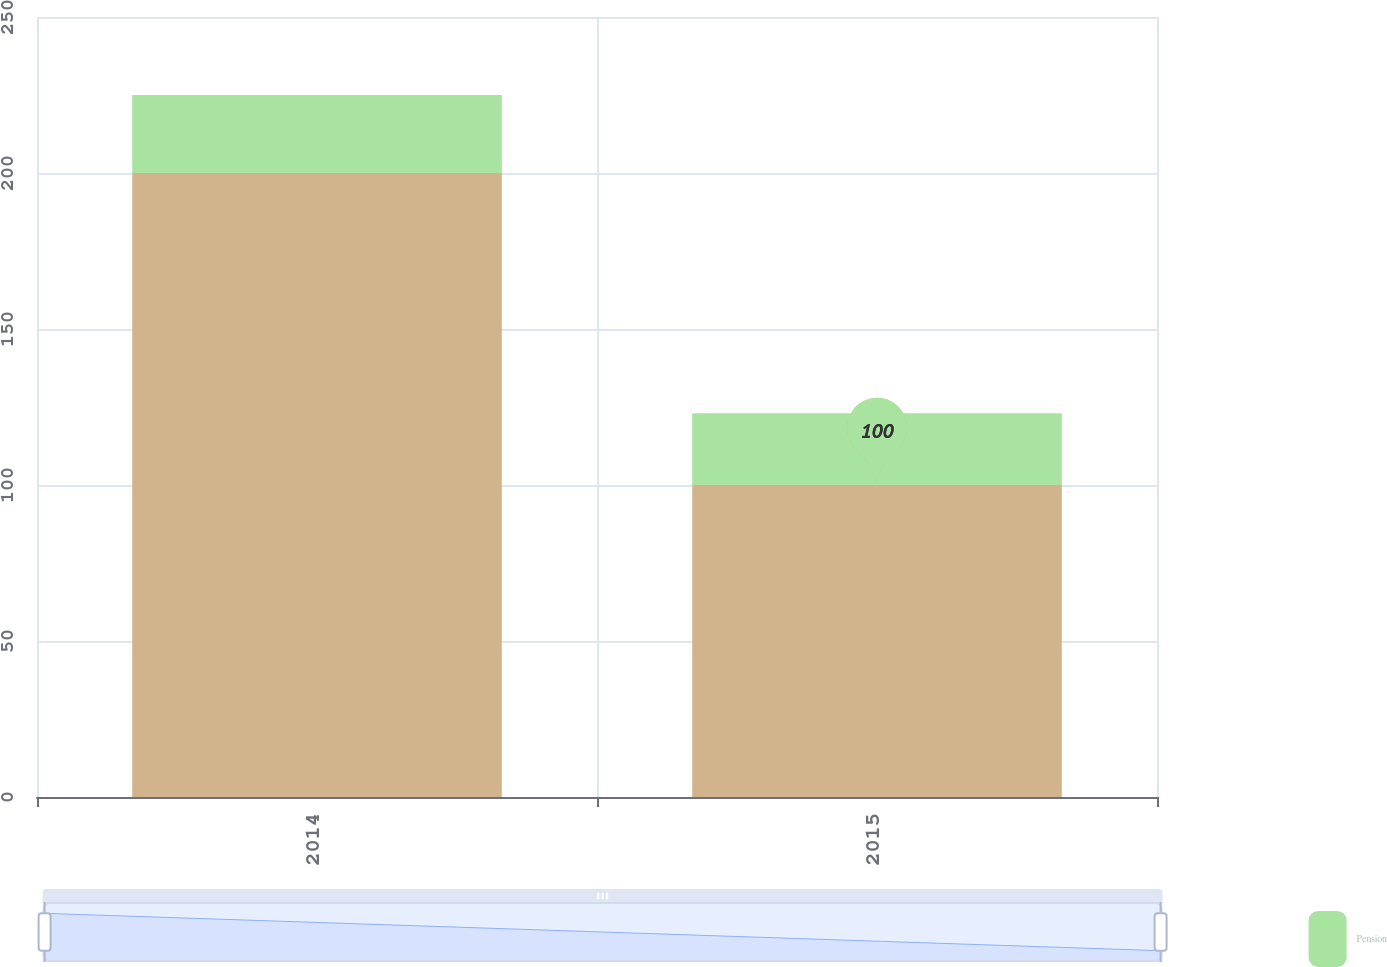Convert chart to OTSL. <chart><loc_0><loc_0><loc_500><loc_500><stacked_bar_chart><ecel><fcel>2014<fcel>2015<nl><fcel>nan<fcel>200<fcel>100<nl><fcel>Pension<fcel>25<fcel>23<nl></chart> 